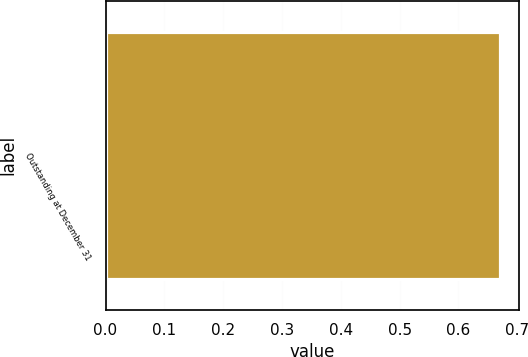<chart> <loc_0><loc_0><loc_500><loc_500><bar_chart><fcel>Outstanding at December 31<nl><fcel>0.67<nl></chart> 